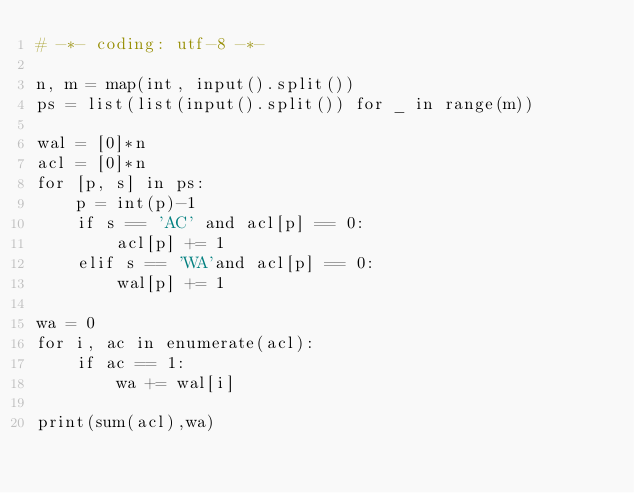Convert code to text. <code><loc_0><loc_0><loc_500><loc_500><_Python_># -*- coding: utf-8 -*-

n, m = map(int, input().split())
ps = list(list(input().split()) for _ in range(m))

wal = [0]*n
acl = [0]*n
for [p, s] in ps:
    p = int(p)-1
    if s == 'AC' and acl[p] == 0:
        acl[p] += 1
    elif s == 'WA'and acl[p] == 0:
        wal[p] += 1

wa = 0
for i, ac in enumerate(acl):
    if ac == 1:
        wa += wal[i]

print(sum(acl),wa)</code> 